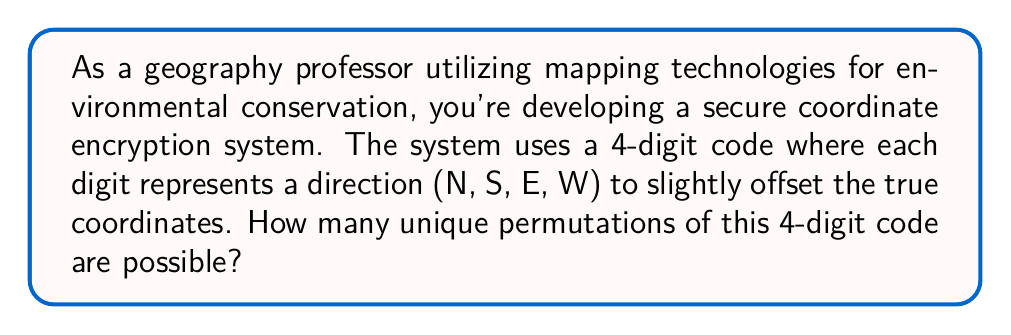What is the answer to this math problem? To solve this problem, we need to follow these steps:

1) First, let's identify the number of choices for each digit in the code:
   There are 4 possible directions (N, S, E, W) for each digit.

2) Now, we need to determine how many times we're making this choice:
   The code is 4 digits long, so we're making this choice 4 times.

3) Since the order matters (it's a permutation) and we can repeat directions, this is a case of permutation with repetition.

4) The formula for permutation with repetition is:

   $$n^r$$

   Where $n$ is the number of choices for each position, and $r$ is the number of positions.

5) In this case:
   $n = 4$ (four directions)
   $r = 4$ (four-digit code)

6) Plugging these values into our formula:

   $$4^4 = 4 \times 4 \times 4 \times 4 = 256$$

Therefore, there are 256 possible unique permutations of the 4-digit code in this coordinate encryption system.
Answer: 256 